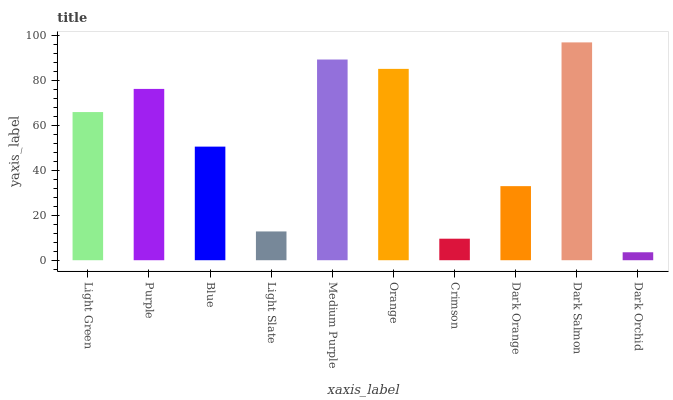Is Dark Orchid the minimum?
Answer yes or no. Yes. Is Dark Salmon the maximum?
Answer yes or no. Yes. Is Purple the minimum?
Answer yes or no. No. Is Purple the maximum?
Answer yes or no. No. Is Purple greater than Light Green?
Answer yes or no. Yes. Is Light Green less than Purple?
Answer yes or no. Yes. Is Light Green greater than Purple?
Answer yes or no. No. Is Purple less than Light Green?
Answer yes or no. No. Is Light Green the high median?
Answer yes or no. Yes. Is Blue the low median?
Answer yes or no. Yes. Is Crimson the high median?
Answer yes or no. No. Is Crimson the low median?
Answer yes or no. No. 